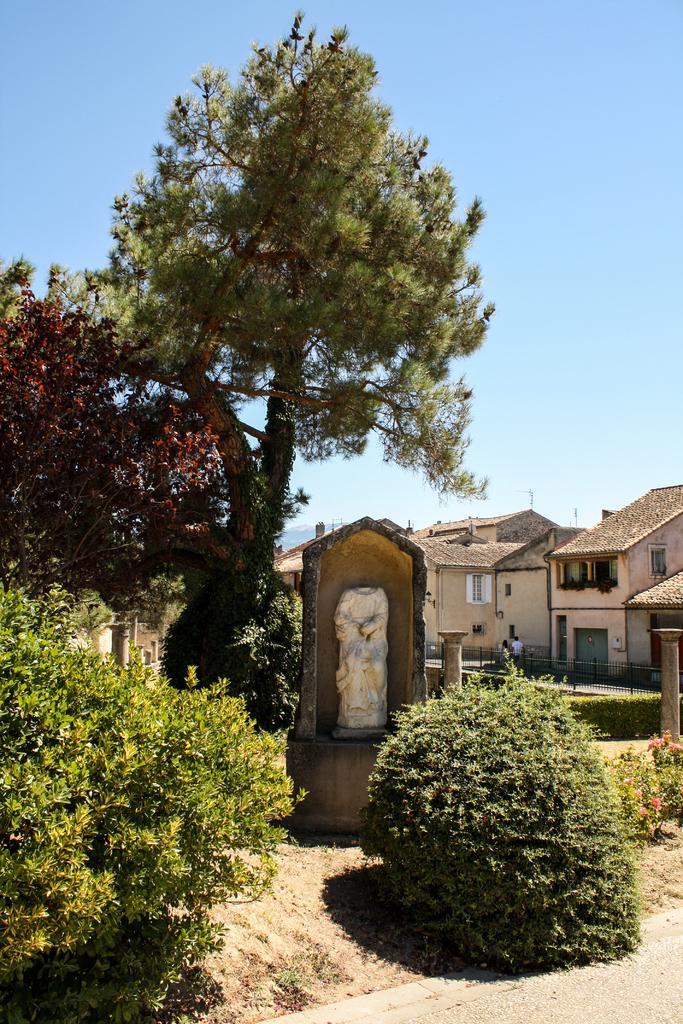Could you give a brief overview of what you see in this image? In this image we can see trees, plants, statue on a platform. In the background there are houses, few persons, windows, roofs and sky. 